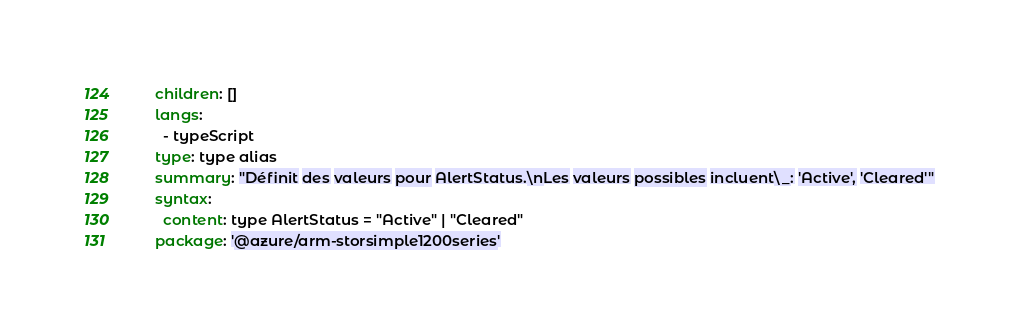Convert code to text. <code><loc_0><loc_0><loc_500><loc_500><_YAML_>    children: []
    langs:
      - typeScript
    type: type alias
    summary: "Définit des valeurs pour AlertStatus.\nLes valeurs possibles incluent\_: 'Active', 'Cleared'"
    syntax:
      content: type AlertStatus = "Active" | "Cleared"
    package: '@azure/arm-storsimple1200series'</code> 